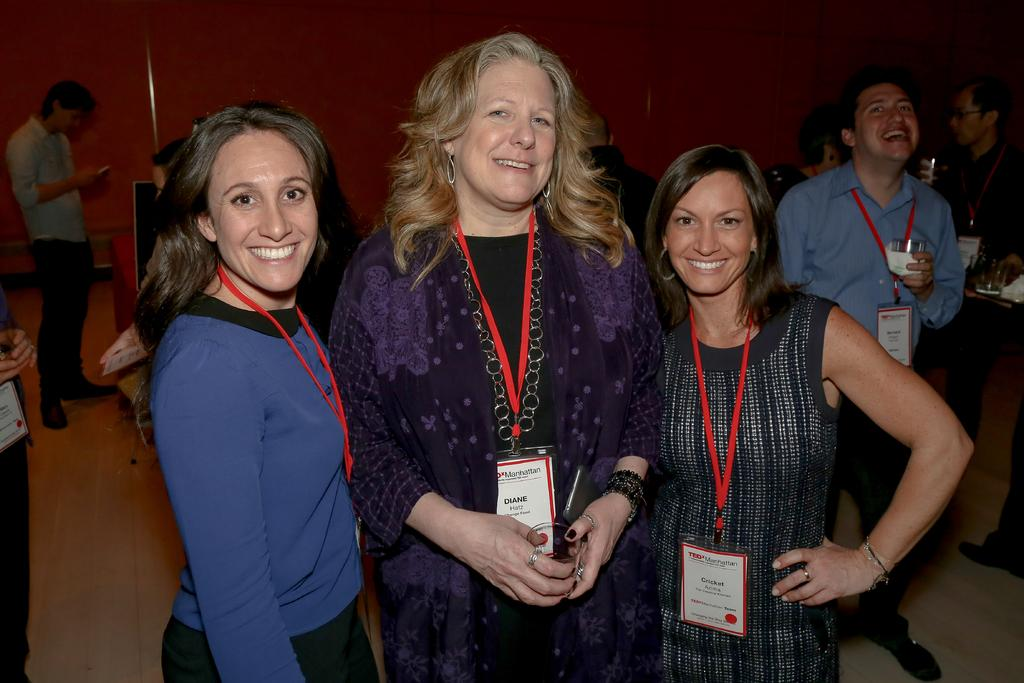What are the people in the image doing? The people in the image are standing on the floor. What are some of the people holding in the image? Some people are holding glasses in the image. What can be seen in the background of the image? There is a wall and a black color object in the background of the image. What type of trouble are the kittens causing in the image? There are no kittens present in the image, so it is not possible to determine if they are causing any trouble. 